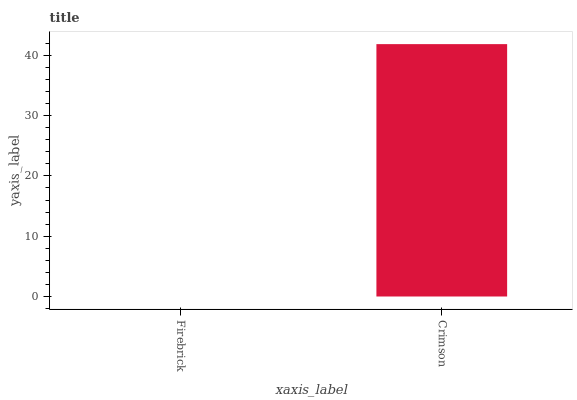Is Firebrick the minimum?
Answer yes or no. Yes. Is Crimson the maximum?
Answer yes or no. Yes. Is Crimson the minimum?
Answer yes or no. No. Is Crimson greater than Firebrick?
Answer yes or no. Yes. Is Firebrick less than Crimson?
Answer yes or no. Yes. Is Firebrick greater than Crimson?
Answer yes or no. No. Is Crimson less than Firebrick?
Answer yes or no. No. Is Crimson the high median?
Answer yes or no. Yes. Is Firebrick the low median?
Answer yes or no. Yes. Is Firebrick the high median?
Answer yes or no. No. Is Crimson the low median?
Answer yes or no. No. 